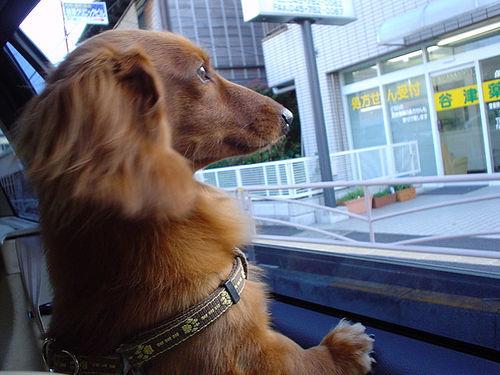What continent is this?
Short answer required. Asia. Is this a dog?
Concise answer only. Yes. What is the breed of the dog?
Short answer required. Dachshund. Where is the dog?
Short answer required. Car. 